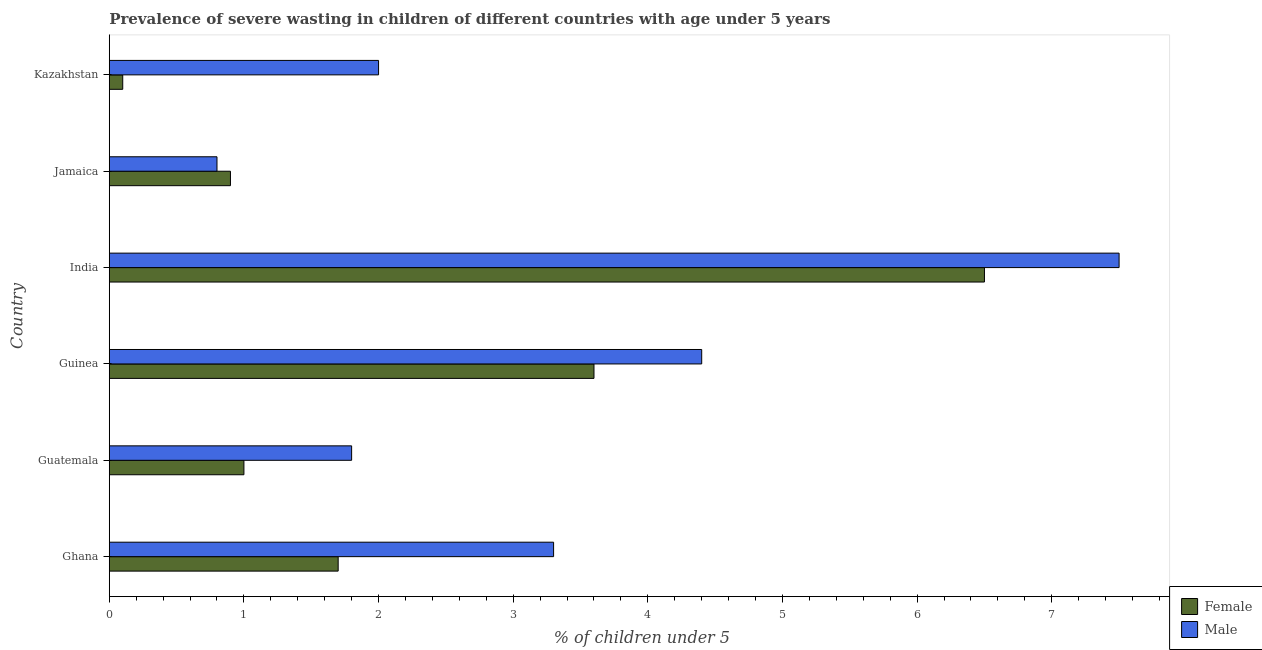How many groups of bars are there?
Offer a terse response. 6. Are the number of bars per tick equal to the number of legend labels?
Provide a succinct answer. Yes. How many bars are there on the 6th tick from the top?
Your answer should be very brief. 2. What is the percentage of undernourished female children in Jamaica?
Ensure brevity in your answer.  0.9. Across all countries, what is the minimum percentage of undernourished male children?
Ensure brevity in your answer.  0.8. In which country was the percentage of undernourished male children minimum?
Ensure brevity in your answer.  Jamaica. What is the total percentage of undernourished male children in the graph?
Give a very brief answer. 19.8. What is the difference between the percentage of undernourished female children in Jamaica and the percentage of undernourished male children in India?
Give a very brief answer. -6.6. What is the ratio of the percentage of undernourished male children in Ghana to that in Jamaica?
Keep it short and to the point. 4.12. Is the difference between the percentage of undernourished female children in Guatemala and Jamaica greater than the difference between the percentage of undernourished male children in Guatemala and Jamaica?
Provide a short and direct response. No. In how many countries, is the percentage of undernourished male children greater than the average percentage of undernourished male children taken over all countries?
Provide a short and direct response. 2. Is the sum of the percentage of undernourished male children in India and Jamaica greater than the maximum percentage of undernourished female children across all countries?
Ensure brevity in your answer.  Yes. What does the 1st bar from the top in Guinea represents?
Ensure brevity in your answer.  Male. What does the 1st bar from the bottom in India represents?
Make the answer very short. Female. Are all the bars in the graph horizontal?
Your answer should be compact. Yes. How many countries are there in the graph?
Provide a short and direct response. 6. What is the difference between two consecutive major ticks on the X-axis?
Provide a succinct answer. 1. Does the graph contain grids?
Keep it short and to the point. No. Where does the legend appear in the graph?
Offer a very short reply. Bottom right. How many legend labels are there?
Offer a very short reply. 2. What is the title of the graph?
Provide a succinct answer. Prevalence of severe wasting in children of different countries with age under 5 years. What is the label or title of the X-axis?
Offer a terse response.  % of children under 5. What is the label or title of the Y-axis?
Your response must be concise. Country. What is the  % of children under 5 of Female in Ghana?
Your answer should be compact. 1.7. What is the  % of children under 5 of Male in Ghana?
Your answer should be compact. 3.3. What is the  % of children under 5 in Male in Guatemala?
Provide a short and direct response. 1.8. What is the  % of children under 5 in Female in Guinea?
Your answer should be compact. 3.6. What is the  % of children under 5 in Male in Guinea?
Offer a terse response. 4.4. What is the  % of children under 5 of Female in India?
Ensure brevity in your answer.  6.5. What is the  % of children under 5 of Female in Jamaica?
Offer a very short reply. 0.9. What is the  % of children under 5 in Male in Jamaica?
Offer a terse response. 0.8. What is the  % of children under 5 in Female in Kazakhstan?
Make the answer very short. 0.1. What is the  % of children under 5 of Male in Kazakhstan?
Your answer should be very brief. 2. Across all countries, what is the maximum  % of children under 5 of Female?
Provide a succinct answer. 6.5. Across all countries, what is the maximum  % of children under 5 of Male?
Make the answer very short. 7.5. Across all countries, what is the minimum  % of children under 5 of Female?
Make the answer very short. 0.1. Across all countries, what is the minimum  % of children under 5 of Male?
Offer a very short reply. 0.8. What is the total  % of children under 5 of Female in the graph?
Ensure brevity in your answer.  13.8. What is the total  % of children under 5 in Male in the graph?
Your answer should be very brief. 19.8. What is the difference between the  % of children under 5 of Female in Ghana and that in Guatemala?
Keep it short and to the point. 0.7. What is the difference between the  % of children under 5 in Female in Ghana and that in Guinea?
Make the answer very short. -1.9. What is the difference between the  % of children under 5 of Male in Ghana and that in Guinea?
Offer a very short reply. -1.1. What is the difference between the  % of children under 5 of Female in Ghana and that in India?
Make the answer very short. -4.8. What is the difference between the  % of children under 5 of Male in Ghana and that in India?
Provide a short and direct response. -4.2. What is the difference between the  % of children under 5 in Female in Ghana and that in Jamaica?
Ensure brevity in your answer.  0.8. What is the difference between the  % of children under 5 of Female in Ghana and that in Kazakhstan?
Make the answer very short. 1.6. What is the difference between the  % of children under 5 of Female in Guatemala and that in India?
Your response must be concise. -5.5. What is the difference between the  % of children under 5 in Male in Guatemala and that in Jamaica?
Offer a very short reply. 1. What is the difference between the  % of children under 5 of Male in Guinea and that in Jamaica?
Offer a terse response. 3.6. What is the difference between the  % of children under 5 of Female in India and that in Jamaica?
Give a very brief answer. 5.6. What is the difference between the  % of children under 5 in Male in India and that in Kazakhstan?
Make the answer very short. 5.5. What is the difference between the  % of children under 5 in Female in Ghana and the  % of children under 5 in Male in Jamaica?
Your answer should be very brief. 0.9. What is the difference between the  % of children under 5 of Female in Guatemala and the  % of children under 5 of Male in India?
Keep it short and to the point. -6.5. What is the difference between the  % of children under 5 in Female in Jamaica and the  % of children under 5 in Male in Kazakhstan?
Give a very brief answer. -1.1. What is the average  % of children under 5 in Male per country?
Offer a very short reply. 3.3. What is the difference between the  % of children under 5 of Female and  % of children under 5 of Male in India?
Your answer should be very brief. -1. What is the ratio of the  % of children under 5 in Female in Ghana to that in Guatemala?
Offer a terse response. 1.7. What is the ratio of the  % of children under 5 of Male in Ghana to that in Guatemala?
Ensure brevity in your answer.  1.83. What is the ratio of the  % of children under 5 in Female in Ghana to that in Guinea?
Provide a short and direct response. 0.47. What is the ratio of the  % of children under 5 of Female in Ghana to that in India?
Make the answer very short. 0.26. What is the ratio of the  % of children under 5 in Male in Ghana to that in India?
Ensure brevity in your answer.  0.44. What is the ratio of the  % of children under 5 in Female in Ghana to that in Jamaica?
Your response must be concise. 1.89. What is the ratio of the  % of children under 5 in Male in Ghana to that in Jamaica?
Offer a very short reply. 4.12. What is the ratio of the  % of children under 5 of Male in Ghana to that in Kazakhstan?
Your answer should be very brief. 1.65. What is the ratio of the  % of children under 5 in Female in Guatemala to that in Guinea?
Give a very brief answer. 0.28. What is the ratio of the  % of children under 5 in Male in Guatemala to that in Guinea?
Keep it short and to the point. 0.41. What is the ratio of the  % of children under 5 of Female in Guatemala to that in India?
Your response must be concise. 0.15. What is the ratio of the  % of children under 5 in Male in Guatemala to that in India?
Ensure brevity in your answer.  0.24. What is the ratio of the  % of children under 5 in Female in Guatemala to that in Jamaica?
Your answer should be compact. 1.11. What is the ratio of the  % of children under 5 of Male in Guatemala to that in Jamaica?
Offer a very short reply. 2.25. What is the ratio of the  % of children under 5 in Male in Guatemala to that in Kazakhstan?
Your answer should be compact. 0.9. What is the ratio of the  % of children under 5 of Female in Guinea to that in India?
Your response must be concise. 0.55. What is the ratio of the  % of children under 5 of Male in Guinea to that in India?
Provide a short and direct response. 0.59. What is the ratio of the  % of children under 5 of Female in Guinea to that in Jamaica?
Offer a terse response. 4. What is the ratio of the  % of children under 5 of Male in Guinea to that in Jamaica?
Offer a terse response. 5.5. What is the ratio of the  % of children under 5 of Female in India to that in Jamaica?
Your answer should be compact. 7.22. What is the ratio of the  % of children under 5 of Male in India to that in Jamaica?
Offer a terse response. 9.38. What is the ratio of the  % of children under 5 in Male in India to that in Kazakhstan?
Ensure brevity in your answer.  3.75. What is the ratio of the  % of children under 5 of Male in Jamaica to that in Kazakhstan?
Keep it short and to the point. 0.4. What is the difference between the highest and the second highest  % of children under 5 in Male?
Your answer should be compact. 3.1. What is the difference between the highest and the lowest  % of children under 5 in Male?
Offer a terse response. 6.7. 